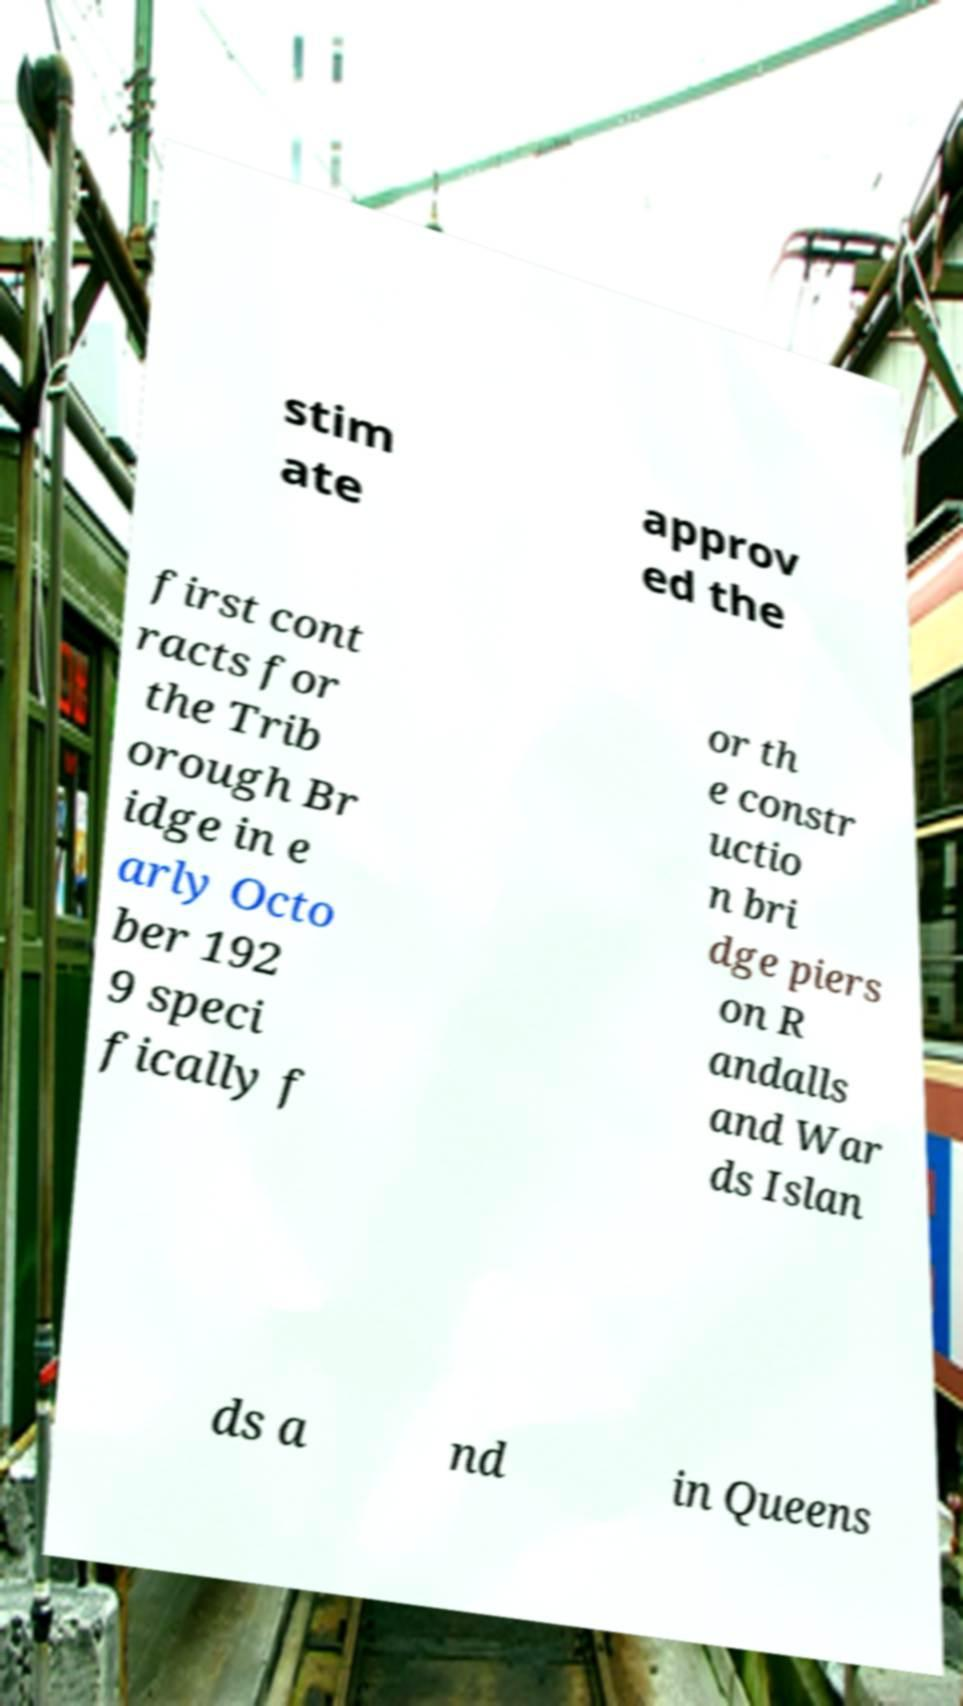For documentation purposes, I need the text within this image transcribed. Could you provide that? stim ate approv ed the first cont racts for the Trib orough Br idge in e arly Octo ber 192 9 speci fically f or th e constr uctio n bri dge piers on R andalls and War ds Islan ds a nd in Queens 